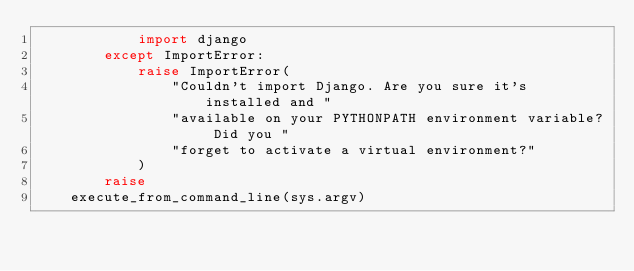Convert code to text. <code><loc_0><loc_0><loc_500><loc_500><_Python_>            import django
        except ImportError:
            raise ImportError(
                "Couldn't import Django. Are you sure it's installed and "
                "available on your PYTHONPATH environment variable? Did you "
                "forget to activate a virtual environment?"
            )
        raise
    execute_from_command_line(sys.argv)
</code> 